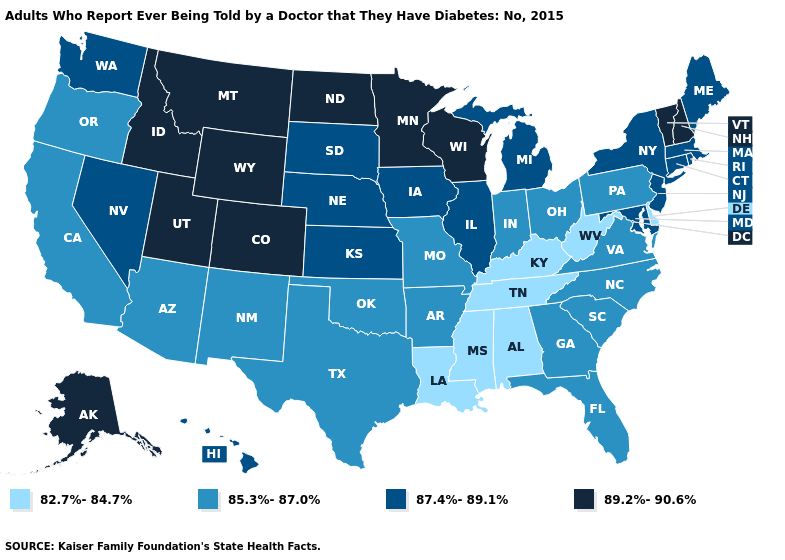Among the states that border Ohio , which have the lowest value?
Concise answer only. Kentucky, West Virginia. What is the value of New Jersey?
Give a very brief answer. 87.4%-89.1%. Name the states that have a value in the range 85.3%-87.0%?
Give a very brief answer. Arizona, Arkansas, California, Florida, Georgia, Indiana, Missouri, New Mexico, North Carolina, Ohio, Oklahoma, Oregon, Pennsylvania, South Carolina, Texas, Virginia. Does Utah have the same value as Wyoming?
Give a very brief answer. Yes. Which states hav the highest value in the MidWest?
Give a very brief answer. Minnesota, North Dakota, Wisconsin. Among the states that border Montana , which have the highest value?
Answer briefly. Idaho, North Dakota, Wyoming. What is the highest value in the USA?
Answer briefly. 89.2%-90.6%. Does California have a lower value than Washington?
Answer briefly. Yes. What is the value of Ohio?
Keep it brief. 85.3%-87.0%. What is the highest value in the USA?
Concise answer only. 89.2%-90.6%. Among the states that border Iowa , does Missouri have the lowest value?
Give a very brief answer. Yes. What is the highest value in the West ?
Concise answer only. 89.2%-90.6%. Name the states that have a value in the range 85.3%-87.0%?
Keep it brief. Arizona, Arkansas, California, Florida, Georgia, Indiana, Missouri, New Mexico, North Carolina, Ohio, Oklahoma, Oregon, Pennsylvania, South Carolina, Texas, Virginia. What is the value of Arkansas?
Quick response, please. 85.3%-87.0%. Does Maryland have the highest value in the South?
Be succinct. Yes. 